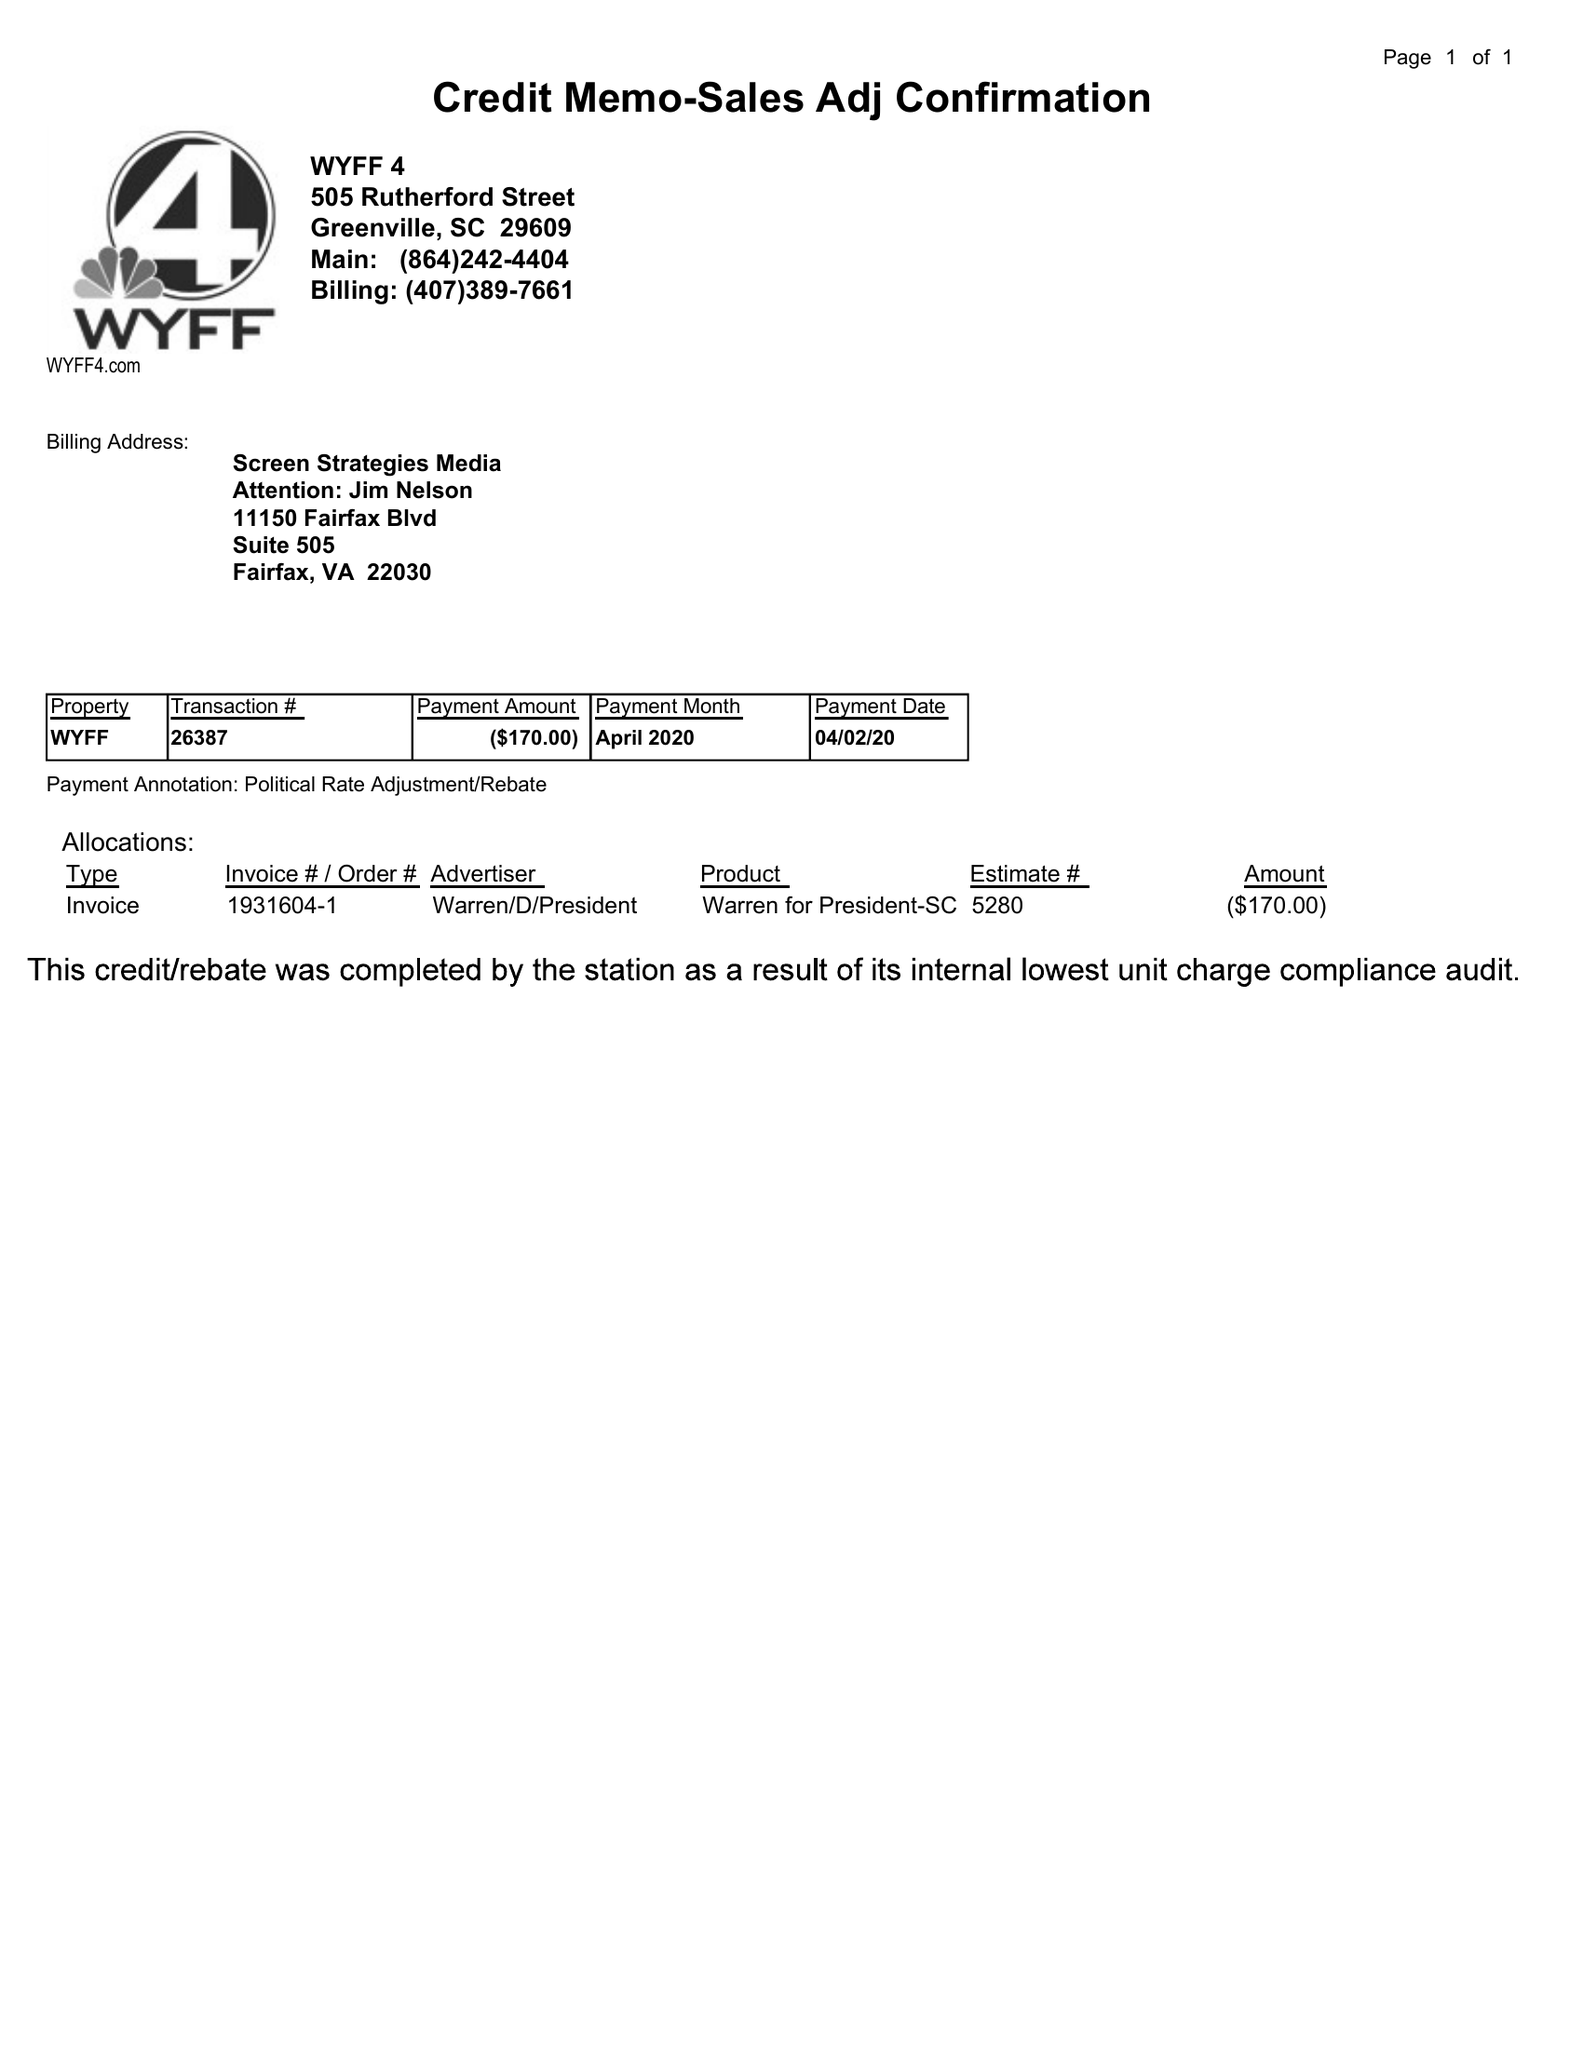What is the value for the flight_to?
Answer the question using a single word or phrase. None 